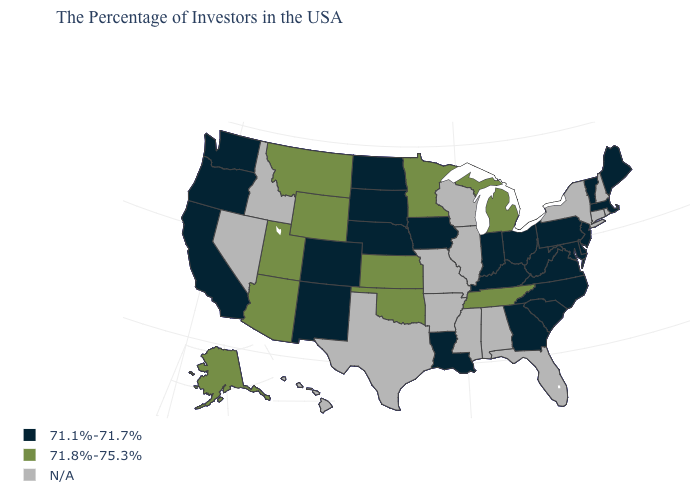What is the value of Maine?
Short answer required. 71.1%-71.7%. What is the value of New Mexico?
Concise answer only. 71.1%-71.7%. What is the value of New Mexico?
Be succinct. 71.1%-71.7%. Which states have the highest value in the USA?
Quick response, please. Michigan, Tennessee, Minnesota, Kansas, Oklahoma, Wyoming, Utah, Montana, Arizona, Alaska. What is the highest value in the West ?
Quick response, please. 71.8%-75.3%. Among the states that border Florida , which have the lowest value?
Give a very brief answer. Georgia. Name the states that have a value in the range 71.1%-71.7%?
Give a very brief answer. Maine, Massachusetts, Vermont, New Jersey, Delaware, Maryland, Pennsylvania, Virginia, North Carolina, South Carolina, West Virginia, Ohio, Georgia, Kentucky, Indiana, Louisiana, Iowa, Nebraska, South Dakota, North Dakota, Colorado, New Mexico, California, Washington, Oregon. Name the states that have a value in the range 71.8%-75.3%?
Short answer required. Michigan, Tennessee, Minnesota, Kansas, Oklahoma, Wyoming, Utah, Montana, Arizona, Alaska. Does Wyoming have the highest value in the USA?
Concise answer only. Yes. Does Minnesota have the lowest value in the MidWest?
Short answer required. No. What is the value of Maine?
Be succinct. 71.1%-71.7%. Which states hav the highest value in the MidWest?
Give a very brief answer. Michigan, Minnesota, Kansas. What is the value of North Carolina?
Concise answer only. 71.1%-71.7%. 